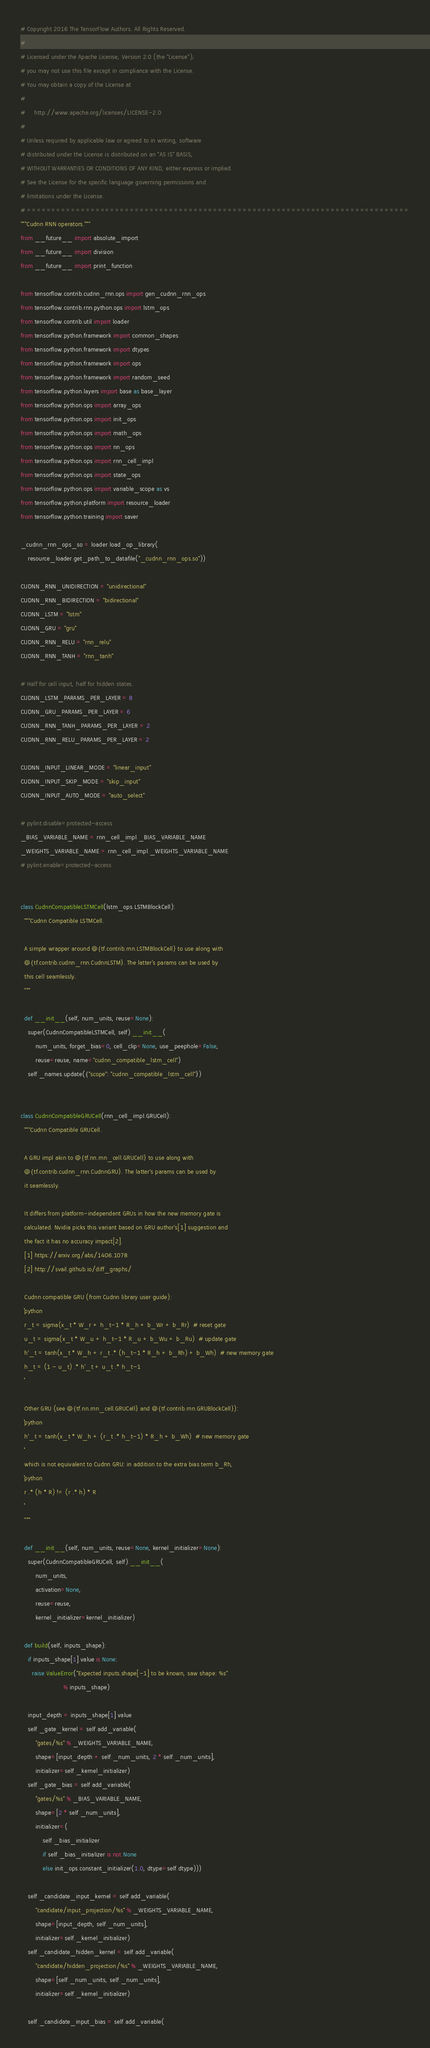<code> <loc_0><loc_0><loc_500><loc_500><_Python_># Copyright 2016 The TensorFlow Authors. All Rights Reserved.
#
# Licensed under the Apache License, Version 2.0 (the "License");
# you may not use this file except in compliance with the License.
# You may obtain a copy of the License at
#
#     http://www.apache.org/licenses/LICENSE-2.0
#
# Unless required by applicable law or agreed to in writing, software
# distributed under the License is distributed on an "AS IS" BASIS,
# WITHOUT WARRANTIES OR CONDITIONS OF ANY KIND, either express or implied.
# See the License for the specific language governing permissions and
# limitations under the License.
# ==============================================================================
"""Cudnn RNN operators."""
from __future__ import absolute_import
from __future__ import division
from __future__ import print_function

from tensorflow.contrib.cudnn_rnn.ops import gen_cudnn_rnn_ops
from tensorflow.contrib.rnn.python.ops import lstm_ops
from tensorflow.contrib.util import loader
from tensorflow.python.framework import common_shapes
from tensorflow.python.framework import dtypes
from tensorflow.python.framework import ops
from tensorflow.python.framework import random_seed
from tensorflow.python.layers import base as base_layer
from tensorflow.python.ops import array_ops
from tensorflow.python.ops import init_ops
from tensorflow.python.ops import math_ops
from tensorflow.python.ops import nn_ops
from tensorflow.python.ops import rnn_cell_impl
from tensorflow.python.ops import state_ops
from tensorflow.python.ops import variable_scope as vs
from tensorflow.python.platform import resource_loader
from tensorflow.python.training import saver

_cudnn_rnn_ops_so = loader.load_op_library(
    resource_loader.get_path_to_datafile("_cudnn_rnn_ops.so"))

CUDNN_RNN_UNIDIRECTION = "unidirectional"
CUDNN_RNN_BIDIRECTION = "bidirectional"
CUDNN_LSTM = "lstm"
CUDNN_GRU = "gru"
CUDNN_RNN_RELU = "rnn_relu"
CUDNN_RNN_TANH = "rnn_tanh"

# Half for cell input, half for hidden states.
CUDNN_LSTM_PARAMS_PER_LAYER = 8
CUDNN_GRU_PARAMS_PER_LAYER = 6
CUDNN_RNN_TANH_PARAMS_PER_LAYER = 2
CUDNN_RNN_RELU_PARAMS_PER_LAYER = 2

CUDNN_INPUT_LINEAR_MODE = "linear_input"
CUDNN_INPUT_SKIP_MODE = "skip_input"
CUDNN_INPUT_AUTO_MODE = "auto_select"

# pylint:disable=protected-access
_BIAS_VARIABLE_NAME = rnn_cell_impl._BIAS_VARIABLE_NAME
_WEIGHTS_VARIABLE_NAME = rnn_cell_impl._WEIGHTS_VARIABLE_NAME
# pylint:enable=protected-access


class CudnnCompatibleLSTMCell(lstm_ops.LSTMBlockCell):
  """Cudnn Compatible LSTMCell.

  A simple wrapper around @{tf.contrib.rnn.LSTMBlockCell} to use along with
  @{tf.contrib.cudnn_rnn.CudnnLSTM}. The latter's params can be used by
  this cell seamlessly.
  """

  def __init__(self, num_units, reuse=None):
    super(CudnnCompatibleLSTMCell, self).__init__(
        num_units, forget_bias=0, cell_clip=None, use_peephole=False,
        reuse=reuse, name="cudnn_compatible_lstm_cell")
    self._names.update({"scope": "cudnn_compatible_lstm_cell"})


class CudnnCompatibleGRUCell(rnn_cell_impl.GRUCell):
  """Cudnn Compatible GRUCell.

  A GRU impl akin to @{tf.nn.rnn_cell.GRUCell} to use along with
  @{tf.contrib.cudnn_rnn.CudnnGRU}. The latter's params can be used by
  it seamlessly.

  It differs from platform-independent GRUs in how the new memory gate is
  calculated. Nvidia picks this variant based on GRU author's[1] suggestion and
  the fact it has no accuracy impact[2].
  [1] https://arxiv.org/abs/1406.1078
  [2] http://svail.github.io/diff_graphs/

  Cudnn compatible GRU (from Cudnn library user guide):
  ```python
  r_t = sigma(x_t * W_r + h_t-1 * R_h + b_Wr + b_Rr)  # reset gate
  u_t = sigma(x_t * W_u + h_t-1 * R_u + b_Wu + b_Ru)  # update gate
  h'_t = tanh(x_t * W_h + r_t .* (h_t-1 * R_h + b_Rh) + b_Wh)  # new memory gate
  h_t = (1 - u_t) .* h'_t + u_t .* h_t-1
  ```

  Other GRU (see @{tf.nn.rnn_cell.GRUCell} and @{tf.contrib.rnn.GRUBlockCell}):
  ```python
  h'_t = tanh(x_t * W_h + (r_t .* h_t-1) * R_h + b_Wh)  # new memory gate
  ```
  which is not equivalent to Cudnn GRU: in addition to the extra bias term b_Rh,
  ```python
  r .* (h * R) != (r .* h) * R
  ```
  """

  def __init__(self, num_units, reuse=None, kernel_initializer=None):
    super(CudnnCompatibleGRUCell, self).__init__(
        num_units,
        activation=None,
        reuse=reuse,
        kernel_initializer=kernel_initializer)

  def build(self, inputs_shape):
    if inputs_shape[1].value is None:
      raise ValueError("Expected inputs.shape[-1] to be known, saw shape: %s"
                       % inputs_shape)

    input_depth = inputs_shape[1].value
    self._gate_kernel = self.add_variable(
        "gates/%s" % _WEIGHTS_VARIABLE_NAME,
        shape=[input_depth + self._num_units, 2 * self._num_units],
        initializer=self._kernel_initializer)
    self._gate_bias = self.add_variable(
        "gates/%s" % _BIAS_VARIABLE_NAME,
        shape=[2 * self._num_units],
        initializer=(
            self._bias_initializer
            if self._bias_initializer is not None
            else init_ops.constant_initializer(1.0, dtype=self.dtype)))

    self._candidate_input_kernel = self.add_variable(
        "candidate/input_projection/%s" % _WEIGHTS_VARIABLE_NAME,
        shape=[input_depth, self._num_units],
        initializer=self._kernel_initializer)
    self._candidate_hidden_kernel = self.add_variable(
        "candidate/hidden_projection/%s" % _WEIGHTS_VARIABLE_NAME,
        shape=[self._num_units, self._num_units],
        initializer=self._kernel_initializer)

    self._candidate_input_bias = self.add_variable(</code> 